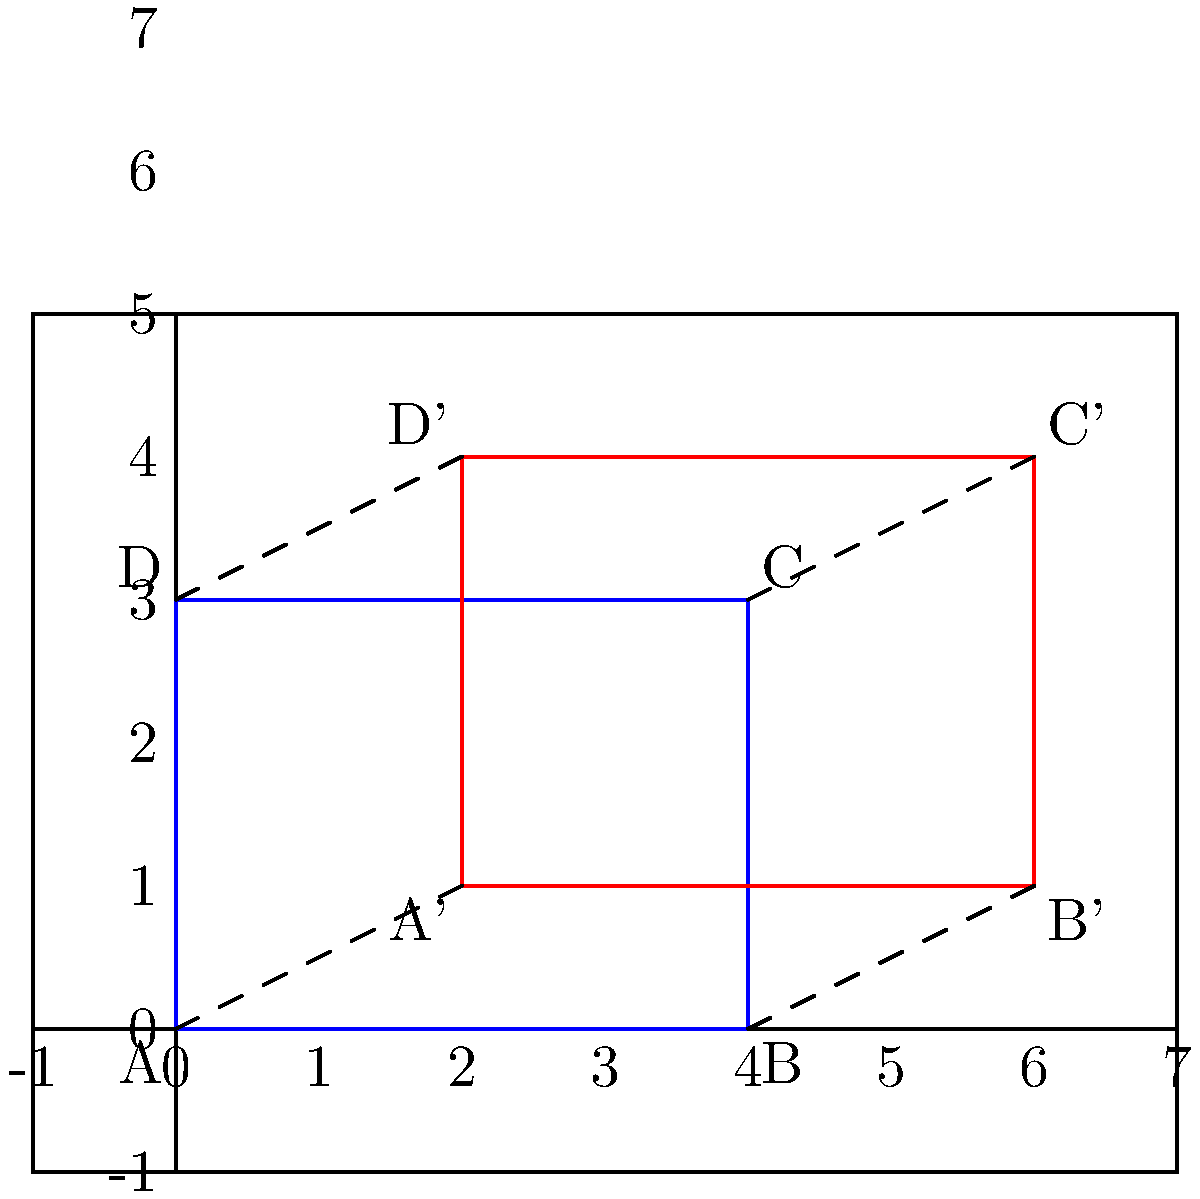As a project lead, you're reviewing a technical author's work on geometric transformations. The author has illustrated two quadrilaterals ABCD and A'B'C'D' in the coordinate plane. Describe the sequence of transformations that maps ABCD onto A'B'C'D', and explain how this proves the congruence of the two quadrilaterals. To prove the congruence of quadrilaterals ABCD and A'B'C'D' using transformations, we can follow these steps:

1. Identify the transformation:
   By observing the coordinates, we can see that A'B'C'D' is a translation of ABCD.

2. Determine the translation vector:
   The translation vector can be found by comparing any pair of corresponding points.
   A(0,0) to A'(2,1): Vector = $\vec{v} = (2,1)$

3. Verify the translation:
   Apply the translation vector to all points of ABCD:
   A(0,0) + (2,1) = A'(2,1)
   B(4,0) + (2,1) = B'(6,1)
   C(4,3) + (2,1) = C'(6,4)
   D(0,3) + (2,1) = D'(2,4)

4. Prove congruence:
   Translations preserve distance and angle measures. Therefore, all corresponding sides and angles of ABCD and A'B'C'D' are congruent.

   - AB ≅ A'B' (length preserved)
   - BC ≅ B'C' (length preserved)
   - CD ≅ C'D' (length preserved)
   - DA ≅ D'A' (length preserved)
   - ∠ABC ≅ ∠A'B'C' (angle measure preserved)
   - ∠BCD ≅ ∠B'C'D' (angle measure preserved)
   - ∠CDA ≅ ∠C'D'A' (angle measure preserved)
   - ∠DAB ≅ ∠D'A'B' (angle measure preserved)

5. Conclusion:
   Since all corresponding sides and angles are congruent, quadrilaterals ABCD and A'B'C'D' are congruent by the definition of congruent polygons.
Answer: Translation by vector $\vec{v} = (2,1)$; translations preserve distance and angle measures, proving congruence. 